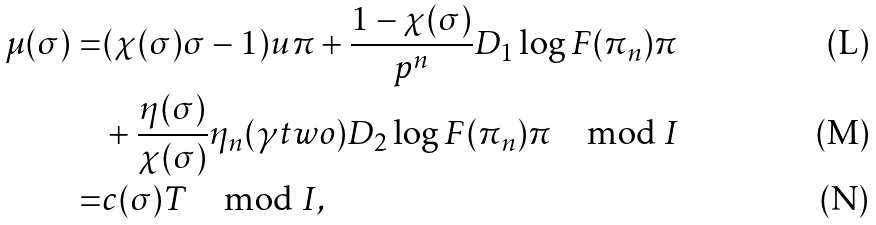<formula> <loc_0><loc_0><loc_500><loc_500>\mu ( \sigma ) = & ( \chi ( \sigma ) \sigma - 1 ) u \pi + \frac { 1 - \chi ( \sigma ) } { p ^ { n } } D _ { 1 } \log F ( \pi _ { n } ) \pi \\ & + \frac { \eta ( \sigma ) } { \chi ( \sigma ) } \eta _ { n } ( \gamma t w o ) D _ { 2 } \log F ( \pi _ { n } ) \pi \mod I \\ = & c ( \sigma ) T \mod I ,</formula> 